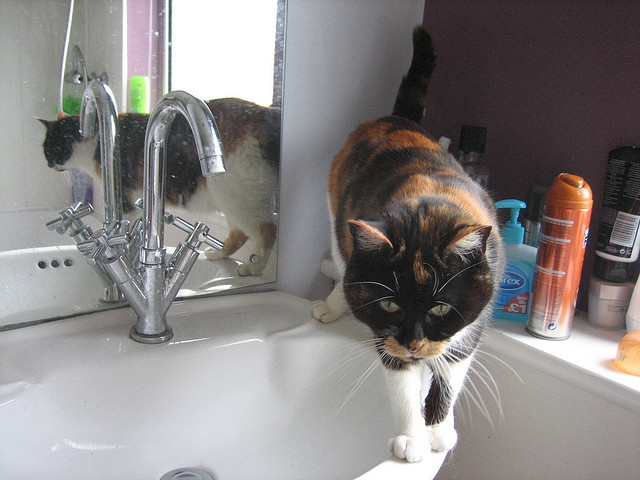Describe the objects in this image and their specific colors. I can see sink in gray, darkgray, and lightgray tones, cat in gray, black, darkgray, and white tones, and bottle in gray, maroon, salmon, and brown tones in this image. 